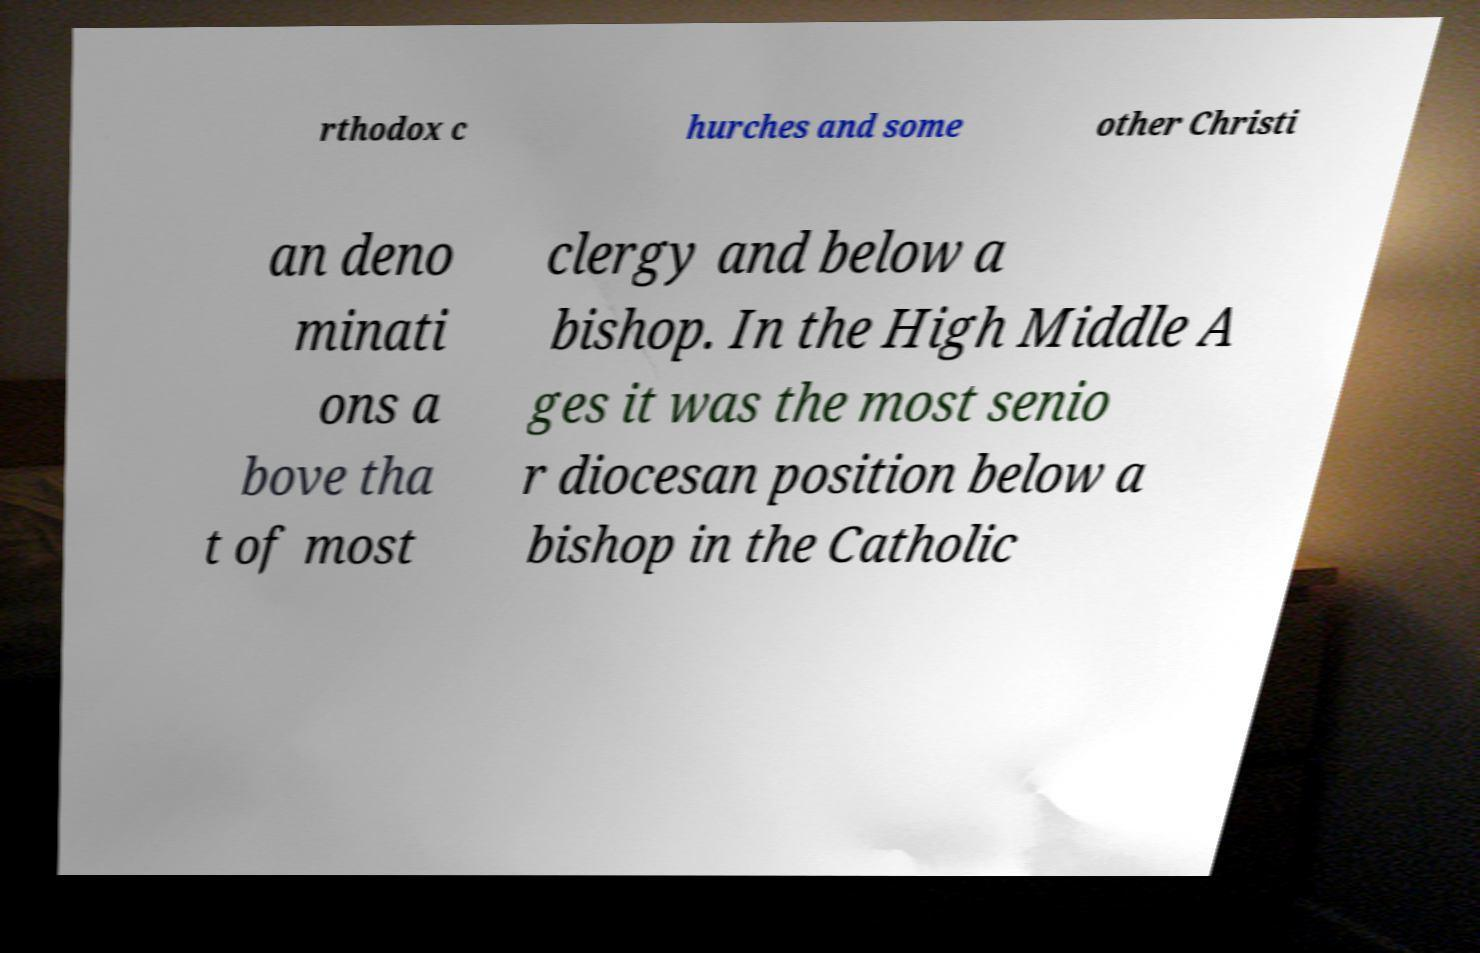Can you accurately transcribe the text from the provided image for me? rthodox c hurches and some other Christi an deno minati ons a bove tha t of most clergy and below a bishop. In the High Middle A ges it was the most senio r diocesan position below a bishop in the Catholic 